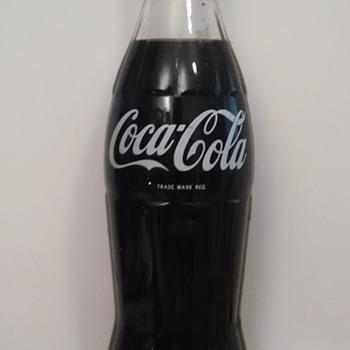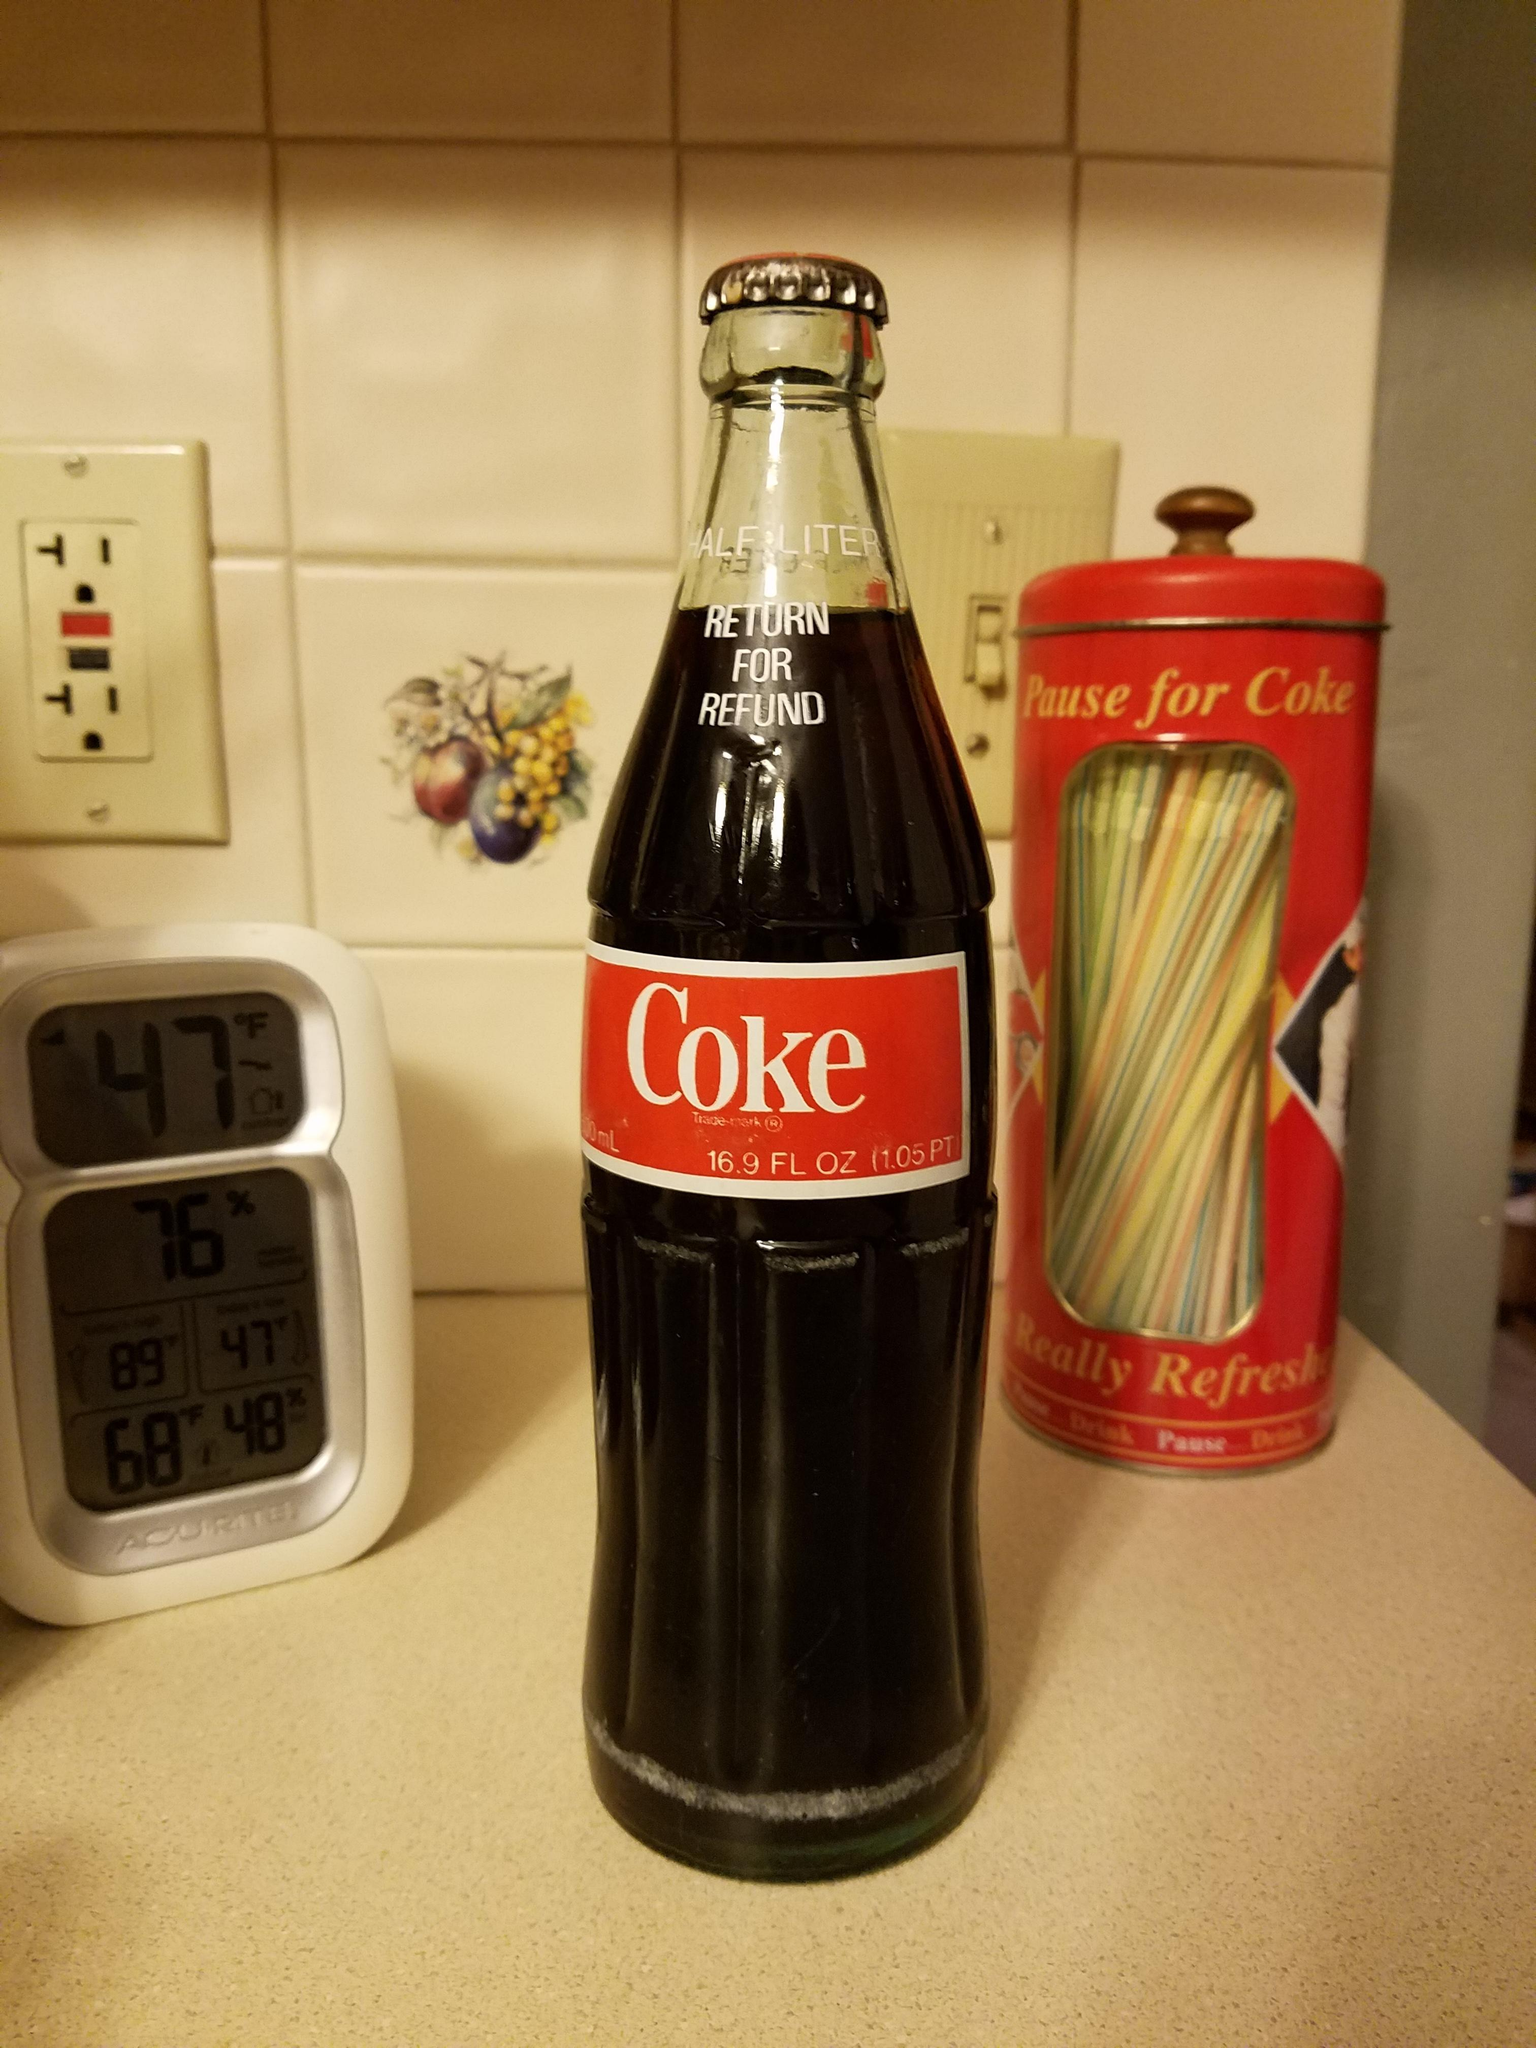The first image is the image on the left, the second image is the image on the right. Analyze the images presented: Is the assertion "At least one soda bottle is written in a foreign language." valid? Answer yes or no. No. The first image is the image on the left, the second image is the image on the right. Considering the images on both sides, is "The bottle in the left image has a partly red label." valid? Answer yes or no. No. 